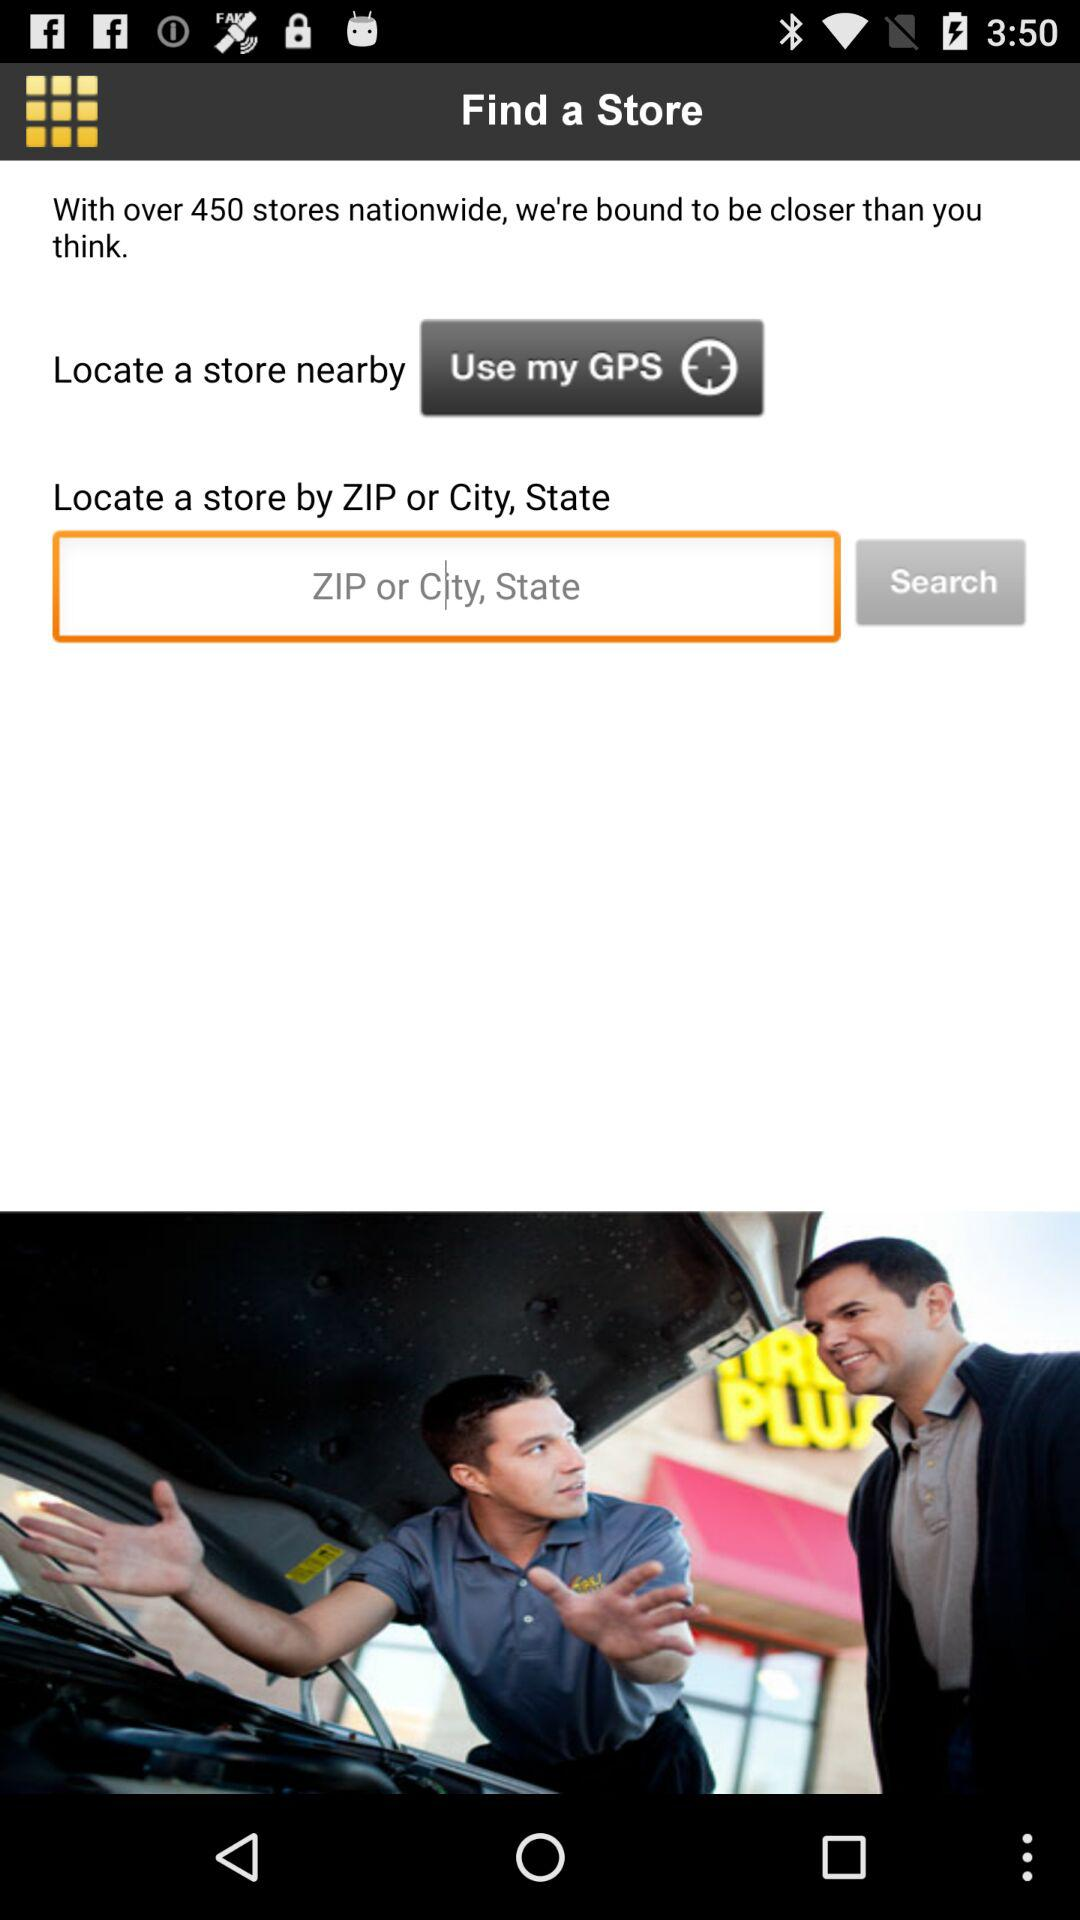How many stores are there nationwide? There are 450 stores nationwide. 